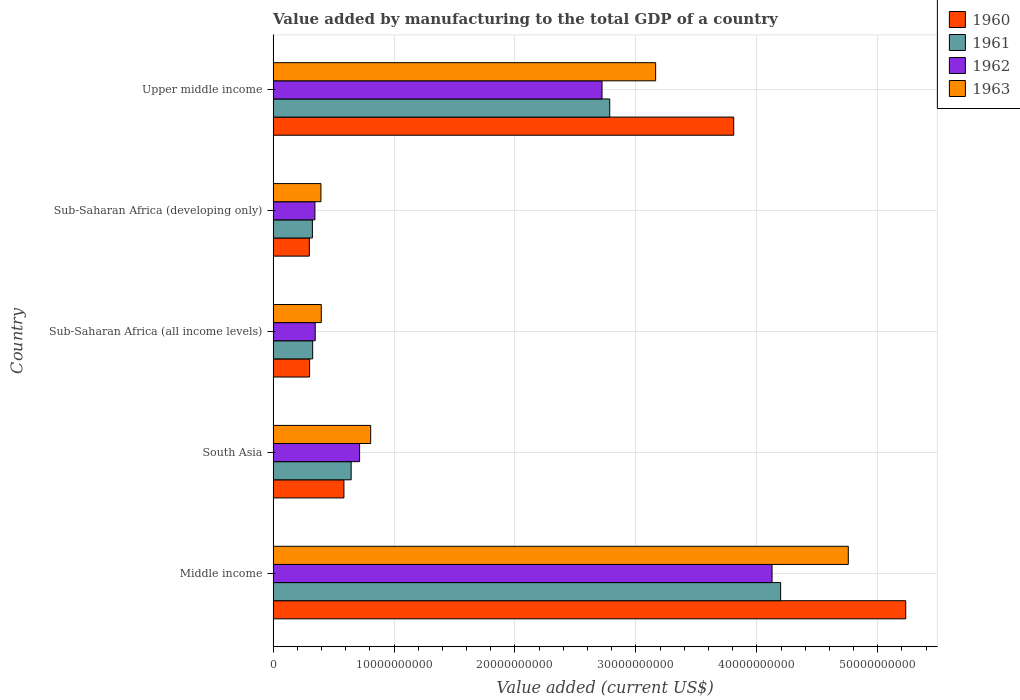How many different coloured bars are there?
Provide a succinct answer. 4. How many groups of bars are there?
Offer a terse response. 5. Are the number of bars per tick equal to the number of legend labels?
Provide a short and direct response. Yes. Are the number of bars on each tick of the Y-axis equal?
Your response must be concise. Yes. How many bars are there on the 4th tick from the bottom?
Make the answer very short. 4. What is the label of the 3rd group of bars from the top?
Keep it short and to the point. Sub-Saharan Africa (all income levels). In how many cases, is the number of bars for a given country not equal to the number of legend labels?
Provide a short and direct response. 0. What is the value added by manufacturing to the total GDP in 1960 in Middle income?
Offer a terse response. 5.23e+1. Across all countries, what is the maximum value added by manufacturing to the total GDP in 1963?
Offer a very short reply. 4.76e+1. Across all countries, what is the minimum value added by manufacturing to the total GDP in 1960?
Provide a succinct answer. 2.99e+09. In which country was the value added by manufacturing to the total GDP in 1963 maximum?
Provide a succinct answer. Middle income. In which country was the value added by manufacturing to the total GDP in 1962 minimum?
Keep it short and to the point. Sub-Saharan Africa (developing only). What is the total value added by manufacturing to the total GDP in 1960 in the graph?
Your answer should be very brief. 1.02e+11. What is the difference between the value added by manufacturing to the total GDP in 1963 in Middle income and that in Upper middle income?
Offer a terse response. 1.59e+1. What is the difference between the value added by manufacturing to the total GDP in 1962 in South Asia and the value added by manufacturing to the total GDP in 1960 in Middle income?
Your answer should be very brief. -4.52e+1. What is the average value added by manufacturing to the total GDP in 1960 per country?
Provide a succinct answer. 2.05e+1. What is the difference between the value added by manufacturing to the total GDP in 1962 and value added by manufacturing to the total GDP in 1961 in Sub-Saharan Africa (developing only)?
Your response must be concise. 2.08e+08. In how many countries, is the value added by manufacturing to the total GDP in 1961 greater than 26000000000 US$?
Provide a short and direct response. 2. What is the ratio of the value added by manufacturing to the total GDP in 1961 in Sub-Saharan Africa (developing only) to that in Upper middle income?
Provide a short and direct response. 0.12. What is the difference between the highest and the second highest value added by manufacturing to the total GDP in 1963?
Your answer should be compact. 1.59e+1. What is the difference between the highest and the lowest value added by manufacturing to the total GDP in 1963?
Ensure brevity in your answer.  4.36e+1. In how many countries, is the value added by manufacturing to the total GDP in 1962 greater than the average value added by manufacturing to the total GDP in 1962 taken over all countries?
Make the answer very short. 2. Is the sum of the value added by manufacturing to the total GDP in 1963 in South Asia and Upper middle income greater than the maximum value added by manufacturing to the total GDP in 1962 across all countries?
Offer a very short reply. No. Is it the case that in every country, the sum of the value added by manufacturing to the total GDP in 1962 and value added by manufacturing to the total GDP in 1961 is greater than the sum of value added by manufacturing to the total GDP in 1960 and value added by manufacturing to the total GDP in 1963?
Your answer should be compact. Yes. What does the 4th bar from the bottom in Sub-Saharan Africa (all income levels) represents?
Offer a terse response. 1963. Is it the case that in every country, the sum of the value added by manufacturing to the total GDP in 1960 and value added by manufacturing to the total GDP in 1962 is greater than the value added by manufacturing to the total GDP in 1961?
Your answer should be compact. Yes. Are the values on the major ticks of X-axis written in scientific E-notation?
Make the answer very short. No. Does the graph contain grids?
Offer a very short reply. Yes. Where does the legend appear in the graph?
Ensure brevity in your answer.  Top right. How are the legend labels stacked?
Keep it short and to the point. Vertical. What is the title of the graph?
Your answer should be compact. Value added by manufacturing to the total GDP of a country. What is the label or title of the X-axis?
Give a very brief answer. Value added (current US$). What is the label or title of the Y-axis?
Make the answer very short. Country. What is the Value added (current US$) of 1960 in Middle income?
Give a very brief answer. 5.23e+1. What is the Value added (current US$) of 1961 in Middle income?
Give a very brief answer. 4.20e+1. What is the Value added (current US$) in 1962 in Middle income?
Make the answer very short. 4.13e+1. What is the Value added (current US$) of 1963 in Middle income?
Your answer should be very brief. 4.76e+1. What is the Value added (current US$) of 1960 in South Asia?
Your answer should be very brief. 5.86e+09. What is the Value added (current US$) in 1961 in South Asia?
Provide a short and direct response. 6.45e+09. What is the Value added (current US$) in 1962 in South Asia?
Your answer should be compact. 7.15e+09. What is the Value added (current US$) in 1963 in South Asia?
Provide a short and direct response. 8.07e+09. What is the Value added (current US$) of 1960 in Sub-Saharan Africa (all income levels)?
Provide a succinct answer. 3.02e+09. What is the Value added (current US$) of 1961 in Sub-Saharan Africa (all income levels)?
Make the answer very short. 3.27e+09. What is the Value added (current US$) of 1962 in Sub-Saharan Africa (all income levels)?
Your answer should be very brief. 3.48e+09. What is the Value added (current US$) of 1963 in Sub-Saharan Africa (all income levels)?
Your answer should be very brief. 3.98e+09. What is the Value added (current US$) in 1960 in Sub-Saharan Africa (developing only)?
Provide a succinct answer. 2.99e+09. What is the Value added (current US$) of 1961 in Sub-Saharan Africa (developing only)?
Your answer should be very brief. 3.25e+09. What is the Value added (current US$) in 1962 in Sub-Saharan Africa (developing only)?
Your answer should be very brief. 3.46e+09. What is the Value added (current US$) of 1963 in Sub-Saharan Africa (developing only)?
Your answer should be very brief. 3.95e+09. What is the Value added (current US$) in 1960 in Upper middle income?
Keep it short and to the point. 3.81e+1. What is the Value added (current US$) in 1961 in Upper middle income?
Your answer should be very brief. 2.78e+1. What is the Value added (current US$) of 1962 in Upper middle income?
Offer a terse response. 2.72e+1. What is the Value added (current US$) of 1963 in Upper middle income?
Provide a succinct answer. 3.16e+1. Across all countries, what is the maximum Value added (current US$) in 1960?
Ensure brevity in your answer.  5.23e+1. Across all countries, what is the maximum Value added (current US$) of 1961?
Offer a very short reply. 4.20e+1. Across all countries, what is the maximum Value added (current US$) in 1962?
Your answer should be very brief. 4.13e+1. Across all countries, what is the maximum Value added (current US$) in 1963?
Your answer should be very brief. 4.76e+1. Across all countries, what is the minimum Value added (current US$) in 1960?
Offer a terse response. 2.99e+09. Across all countries, what is the minimum Value added (current US$) in 1961?
Offer a very short reply. 3.25e+09. Across all countries, what is the minimum Value added (current US$) in 1962?
Offer a terse response. 3.46e+09. Across all countries, what is the minimum Value added (current US$) of 1963?
Your answer should be very brief. 3.95e+09. What is the total Value added (current US$) of 1960 in the graph?
Your answer should be compact. 1.02e+11. What is the total Value added (current US$) in 1961 in the graph?
Your answer should be compact. 8.28e+1. What is the total Value added (current US$) in 1962 in the graph?
Your answer should be very brief. 8.25e+1. What is the total Value added (current US$) of 1963 in the graph?
Your answer should be compact. 9.52e+1. What is the difference between the Value added (current US$) of 1960 in Middle income and that in South Asia?
Your answer should be very brief. 4.65e+1. What is the difference between the Value added (current US$) of 1961 in Middle income and that in South Asia?
Your answer should be very brief. 3.55e+1. What is the difference between the Value added (current US$) in 1962 in Middle income and that in South Asia?
Offer a very short reply. 3.41e+1. What is the difference between the Value added (current US$) in 1963 in Middle income and that in South Asia?
Make the answer very short. 3.95e+1. What is the difference between the Value added (current US$) of 1960 in Middle income and that in Sub-Saharan Africa (all income levels)?
Offer a very short reply. 4.93e+1. What is the difference between the Value added (current US$) in 1961 in Middle income and that in Sub-Saharan Africa (all income levels)?
Keep it short and to the point. 3.87e+1. What is the difference between the Value added (current US$) of 1962 in Middle income and that in Sub-Saharan Africa (all income levels)?
Offer a very short reply. 3.78e+1. What is the difference between the Value added (current US$) of 1963 in Middle income and that in Sub-Saharan Africa (all income levels)?
Your answer should be compact. 4.36e+1. What is the difference between the Value added (current US$) in 1960 in Middle income and that in Sub-Saharan Africa (developing only)?
Make the answer very short. 4.93e+1. What is the difference between the Value added (current US$) of 1961 in Middle income and that in Sub-Saharan Africa (developing only)?
Provide a short and direct response. 3.87e+1. What is the difference between the Value added (current US$) of 1962 in Middle income and that in Sub-Saharan Africa (developing only)?
Your answer should be compact. 3.78e+1. What is the difference between the Value added (current US$) of 1963 in Middle income and that in Sub-Saharan Africa (developing only)?
Make the answer very short. 4.36e+1. What is the difference between the Value added (current US$) in 1960 in Middle income and that in Upper middle income?
Offer a terse response. 1.42e+1. What is the difference between the Value added (current US$) of 1961 in Middle income and that in Upper middle income?
Provide a short and direct response. 1.41e+1. What is the difference between the Value added (current US$) in 1962 in Middle income and that in Upper middle income?
Your response must be concise. 1.41e+1. What is the difference between the Value added (current US$) of 1963 in Middle income and that in Upper middle income?
Make the answer very short. 1.59e+1. What is the difference between the Value added (current US$) in 1960 in South Asia and that in Sub-Saharan Africa (all income levels)?
Provide a succinct answer. 2.84e+09. What is the difference between the Value added (current US$) of 1961 in South Asia and that in Sub-Saharan Africa (all income levels)?
Your answer should be compact. 3.18e+09. What is the difference between the Value added (current US$) of 1962 in South Asia and that in Sub-Saharan Africa (all income levels)?
Make the answer very short. 3.67e+09. What is the difference between the Value added (current US$) in 1963 in South Asia and that in Sub-Saharan Africa (all income levels)?
Provide a succinct answer. 4.08e+09. What is the difference between the Value added (current US$) of 1960 in South Asia and that in Sub-Saharan Africa (developing only)?
Provide a succinct answer. 2.86e+09. What is the difference between the Value added (current US$) of 1961 in South Asia and that in Sub-Saharan Africa (developing only)?
Give a very brief answer. 3.21e+09. What is the difference between the Value added (current US$) of 1962 in South Asia and that in Sub-Saharan Africa (developing only)?
Provide a short and direct response. 3.70e+09. What is the difference between the Value added (current US$) in 1963 in South Asia and that in Sub-Saharan Africa (developing only)?
Provide a short and direct response. 4.11e+09. What is the difference between the Value added (current US$) in 1960 in South Asia and that in Upper middle income?
Provide a succinct answer. -3.22e+1. What is the difference between the Value added (current US$) in 1961 in South Asia and that in Upper middle income?
Provide a succinct answer. -2.14e+1. What is the difference between the Value added (current US$) in 1962 in South Asia and that in Upper middle income?
Your answer should be very brief. -2.00e+1. What is the difference between the Value added (current US$) of 1963 in South Asia and that in Upper middle income?
Keep it short and to the point. -2.36e+1. What is the difference between the Value added (current US$) in 1960 in Sub-Saharan Africa (all income levels) and that in Sub-Saharan Africa (developing only)?
Your answer should be compact. 2.16e+07. What is the difference between the Value added (current US$) of 1961 in Sub-Saharan Africa (all income levels) and that in Sub-Saharan Africa (developing only)?
Keep it short and to the point. 2.34e+07. What is the difference between the Value added (current US$) of 1962 in Sub-Saharan Africa (all income levels) and that in Sub-Saharan Africa (developing only)?
Provide a short and direct response. 2.49e+07. What is the difference between the Value added (current US$) of 1963 in Sub-Saharan Africa (all income levels) and that in Sub-Saharan Africa (developing only)?
Offer a very short reply. 2.85e+07. What is the difference between the Value added (current US$) of 1960 in Sub-Saharan Africa (all income levels) and that in Upper middle income?
Your response must be concise. -3.51e+1. What is the difference between the Value added (current US$) of 1961 in Sub-Saharan Africa (all income levels) and that in Upper middle income?
Keep it short and to the point. -2.46e+1. What is the difference between the Value added (current US$) in 1962 in Sub-Saharan Africa (all income levels) and that in Upper middle income?
Your answer should be compact. -2.37e+1. What is the difference between the Value added (current US$) of 1963 in Sub-Saharan Africa (all income levels) and that in Upper middle income?
Ensure brevity in your answer.  -2.76e+1. What is the difference between the Value added (current US$) in 1960 in Sub-Saharan Africa (developing only) and that in Upper middle income?
Give a very brief answer. -3.51e+1. What is the difference between the Value added (current US$) of 1961 in Sub-Saharan Africa (developing only) and that in Upper middle income?
Provide a succinct answer. -2.46e+1. What is the difference between the Value added (current US$) in 1962 in Sub-Saharan Africa (developing only) and that in Upper middle income?
Your answer should be very brief. -2.37e+1. What is the difference between the Value added (current US$) in 1963 in Sub-Saharan Africa (developing only) and that in Upper middle income?
Offer a terse response. -2.77e+1. What is the difference between the Value added (current US$) of 1960 in Middle income and the Value added (current US$) of 1961 in South Asia?
Make the answer very short. 4.59e+1. What is the difference between the Value added (current US$) of 1960 in Middle income and the Value added (current US$) of 1962 in South Asia?
Provide a short and direct response. 4.52e+1. What is the difference between the Value added (current US$) of 1960 in Middle income and the Value added (current US$) of 1963 in South Asia?
Offer a terse response. 4.42e+1. What is the difference between the Value added (current US$) of 1961 in Middle income and the Value added (current US$) of 1962 in South Asia?
Offer a very short reply. 3.48e+1. What is the difference between the Value added (current US$) in 1961 in Middle income and the Value added (current US$) in 1963 in South Asia?
Give a very brief answer. 3.39e+1. What is the difference between the Value added (current US$) in 1962 in Middle income and the Value added (current US$) in 1963 in South Asia?
Provide a succinct answer. 3.32e+1. What is the difference between the Value added (current US$) of 1960 in Middle income and the Value added (current US$) of 1961 in Sub-Saharan Africa (all income levels)?
Ensure brevity in your answer.  4.90e+1. What is the difference between the Value added (current US$) in 1960 in Middle income and the Value added (current US$) in 1962 in Sub-Saharan Africa (all income levels)?
Provide a succinct answer. 4.88e+1. What is the difference between the Value added (current US$) of 1960 in Middle income and the Value added (current US$) of 1963 in Sub-Saharan Africa (all income levels)?
Offer a very short reply. 4.83e+1. What is the difference between the Value added (current US$) of 1961 in Middle income and the Value added (current US$) of 1962 in Sub-Saharan Africa (all income levels)?
Offer a terse response. 3.85e+1. What is the difference between the Value added (current US$) of 1961 in Middle income and the Value added (current US$) of 1963 in Sub-Saharan Africa (all income levels)?
Provide a short and direct response. 3.80e+1. What is the difference between the Value added (current US$) in 1962 in Middle income and the Value added (current US$) in 1963 in Sub-Saharan Africa (all income levels)?
Your response must be concise. 3.73e+1. What is the difference between the Value added (current US$) in 1960 in Middle income and the Value added (current US$) in 1961 in Sub-Saharan Africa (developing only)?
Provide a succinct answer. 4.91e+1. What is the difference between the Value added (current US$) in 1960 in Middle income and the Value added (current US$) in 1962 in Sub-Saharan Africa (developing only)?
Your answer should be compact. 4.89e+1. What is the difference between the Value added (current US$) of 1960 in Middle income and the Value added (current US$) of 1963 in Sub-Saharan Africa (developing only)?
Offer a very short reply. 4.84e+1. What is the difference between the Value added (current US$) of 1961 in Middle income and the Value added (current US$) of 1962 in Sub-Saharan Africa (developing only)?
Offer a very short reply. 3.85e+1. What is the difference between the Value added (current US$) in 1961 in Middle income and the Value added (current US$) in 1963 in Sub-Saharan Africa (developing only)?
Give a very brief answer. 3.80e+1. What is the difference between the Value added (current US$) in 1962 in Middle income and the Value added (current US$) in 1963 in Sub-Saharan Africa (developing only)?
Your response must be concise. 3.73e+1. What is the difference between the Value added (current US$) of 1960 in Middle income and the Value added (current US$) of 1961 in Upper middle income?
Your answer should be compact. 2.45e+1. What is the difference between the Value added (current US$) of 1960 in Middle income and the Value added (current US$) of 1962 in Upper middle income?
Keep it short and to the point. 2.51e+1. What is the difference between the Value added (current US$) of 1960 in Middle income and the Value added (current US$) of 1963 in Upper middle income?
Keep it short and to the point. 2.07e+1. What is the difference between the Value added (current US$) in 1961 in Middle income and the Value added (current US$) in 1962 in Upper middle income?
Provide a short and direct response. 1.48e+1. What is the difference between the Value added (current US$) of 1961 in Middle income and the Value added (current US$) of 1963 in Upper middle income?
Ensure brevity in your answer.  1.03e+1. What is the difference between the Value added (current US$) of 1962 in Middle income and the Value added (current US$) of 1963 in Upper middle income?
Provide a short and direct response. 9.63e+09. What is the difference between the Value added (current US$) of 1960 in South Asia and the Value added (current US$) of 1961 in Sub-Saharan Africa (all income levels)?
Offer a very short reply. 2.58e+09. What is the difference between the Value added (current US$) in 1960 in South Asia and the Value added (current US$) in 1962 in Sub-Saharan Africa (all income levels)?
Provide a succinct answer. 2.37e+09. What is the difference between the Value added (current US$) in 1960 in South Asia and the Value added (current US$) in 1963 in Sub-Saharan Africa (all income levels)?
Give a very brief answer. 1.87e+09. What is the difference between the Value added (current US$) in 1961 in South Asia and the Value added (current US$) in 1962 in Sub-Saharan Africa (all income levels)?
Your response must be concise. 2.97e+09. What is the difference between the Value added (current US$) in 1961 in South Asia and the Value added (current US$) in 1963 in Sub-Saharan Africa (all income levels)?
Keep it short and to the point. 2.47e+09. What is the difference between the Value added (current US$) in 1962 in South Asia and the Value added (current US$) in 1963 in Sub-Saharan Africa (all income levels)?
Keep it short and to the point. 3.17e+09. What is the difference between the Value added (current US$) in 1960 in South Asia and the Value added (current US$) in 1961 in Sub-Saharan Africa (developing only)?
Ensure brevity in your answer.  2.61e+09. What is the difference between the Value added (current US$) in 1960 in South Asia and the Value added (current US$) in 1962 in Sub-Saharan Africa (developing only)?
Your answer should be compact. 2.40e+09. What is the difference between the Value added (current US$) of 1960 in South Asia and the Value added (current US$) of 1963 in Sub-Saharan Africa (developing only)?
Your answer should be compact. 1.90e+09. What is the difference between the Value added (current US$) of 1961 in South Asia and the Value added (current US$) of 1962 in Sub-Saharan Africa (developing only)?
Your response must be concise. 3.00e+09. What is the difference between the Value added (current US$) of 1961 in South Asia and the Value added (current US$) of 1963 in Sub-Saharan Africa (developing only)?
Offer a very short reply. 2.50e+09. What is the difference between the Value added (current US$) of 1962 in South Asia and the Value added (current US$) of 1963 in Sub-Saharan Africa (developing only)?
Provide a succinct answer. 3.20e+09. What is the difference between the Value added (current US$) in 1960 in South Asia and the Value added (current US$) in 1961 in Upper middle income?
Your answer should be compact. -2.20e+1. What is the difference between the Value added (current US$) of 1960 in South Asia and the Value added (current US$) of 1962 in Upper middle income?
Offer a very short reply. -2.13e+1. What is the difference between the Value added (current US$) of 1960 in South Asia and the Value added (current US$) of 1963 in Upper middle income?
Your response must be concise. -2.58e+1. What is the difference between the Value added (current US$) of 1961 in South Asia and the Value added (current US$) of 1962 in Upper middle income?
Ensure brevity in your answer.  -2.07e+1. What is the difference between the Value added (current US$) of 1961 in South Asia and the Value added (current US$) of 1963 in Upper middle income?
Your response must be concise. -2.52e+1. What is the difference between the Value added (current US$) in 1962 in South Asia and the Value added (current US$) in 1963 in Upper middle income?
Keep it short and to the point. -2.45e+1. What is the difference between the Value added (current US$) of 1960 in Sub-Saharan Africa (all income levels) and the Value added (current US$) of 1961 in Sub-Saharan Africa (developing only)?
Provide a short and direct response. -2.32e+08. What is the difference between the Value added (current US$) in 1960 in Sub-Saharan Africa (all income levels) and the Value added (current US$) in 1962 in Sub-Saharan Africa (developing only)?
Your answer should be compact. -4.40e+08. What is the difference between the Value added (current US$) in 1960 in Sub-Saharan Africa (all income levels) and the Value added (current US$) in 1963 in Sub-Saharan Africa (developing only)?
Offer a very short reply. -9.39e+08. What is the difference between the Value added (current US$) in 1961 in Sub-Saharan Africa (all income levels) and the Value added (current US$) in 1962 in Sub-Saharan Africa (developing only)?
Give a very brief answer. -1.85e+08. What is the difference between the Value added (current US$) of 1961 in Sub-Saharan Africa (all income levels) and the Value added (current US$) of 1963 in Sub-Saharan Africa (developing only)?
Provide a succinct answer. -6.84e+08. What is the difference between the Value added (current US$) of 1962 in Sub-Saharan Africa (all income levels) and the Value added (current US$) of 1963 in Sub-Saharan Africa (developing only)?
Keep it short and to the point. -4.74e+08. What is the difference between the Value added (current US$) of 1960 in Sub-Saharan Africa (all income levels) and the Value added (current US$) of 1961 in Upper middle income?
Ensure brevity in your answer.  -2.48e+1. What is the difference between the Value added (current US$) in 1960 in Sub-Saharan Africa (all income levels) and the Value added (current US$) in 1962 in Upper middle income?
Give a very brief answer. -2.42e+1. What is the difference between the Value added (current US$) of 1960 in Sub-Saharan Africa (all income levels) and the Value added (current US$) of 1963 in Upper middle income?
Offer a terse response. -2.86e+1. What is the difference between the Value added (current US$) of 1961 in Sub-Saharan Africa (all income levels) and the Value added (current US$) of 1962 in Upper middle income?
Keep it short and to the point. -2.39e+1. What is the difference between the Value added (current US$) in 1961 in Sub-Saharan Africa (all income levels) and the Value added (current US$) in 1963 in Upper middle income?
Provide a short and direct response. -2.84e+1. What is the difference between the Value added (current US$) in 1962 in Sub-Saharan Africa (all income levels) and the Value added (current US$) in 1963 in Upper middle income?
Give a very brief answer. -2.82e+1. What is the difference between the Value added (current US$) in 1960 in Sub-Saharan Africa (developing only) and the Value added (current US$) in 1961 in Upper middle income?
Ensure brevity in your answer.  -2.48e+1. What is the difference between the Value added (current US$) in 1960 in Sub-Saharan Africa (developing only) and the Value added (current US$) in 1962 in Upper middle income?
Your answer should be very brief. -2.42e+1. What is the difference between the Value added (current US$) in 1960 in Sub-Saharan Africa (developing only) and the Value added (current US$) in 1963 in Upper middle income?
Offer a terse response. -2.86e+1. What is the difference between the Value added (current US$) in 1961 in Sub-Saharan Africa (developing only) and the Value added (current US$) in 1962 in Upper middle income?
Provide a succinct answer. -2.40e+1. What is the difference between the Value added (current US$) in 1961 in Sub-Saharan Africa (developing only) and the Value added (current US$) in 1963 in Upper middle income?
Your answer should be very brief. -2.84e+1. What is the difference between the Value added (current US$) in 1962 in Sub-Saharan Africa (developing only) and the Value added (current US$) in 1963 in Upper middle income?
Your answer should be compact. -2.82e+1. What is the average Value added (current US$) in 1960 per country?
Ensure brevity in your answer.  2.05e+1. What is the average Value added (current US$) of 1961 per country?
Ensure brevity in your answer.  1.66e+1. What is the average Value added (current US$) of 1962 per country?
Your answer should be compact. 1.65e+1. What is the average Value added (current US$) of 1963 per country?
Your response must be concise. 1.90e+1. What is the difference between the Value added (current US$) in 1960 and Value added (current US$) in 1961 in Middle income?
Your answer should be compact. 1.03e+1. What is the difference between the Value added (current US$) of 1960 and Value added (current US$) of 1962 in Middle income?
Make the answer very short. 1.11e+1. What is the difference between the Value added (current US$) of 1960 and Value added (current US$) of 1963 in Middle income?
Make the answer very short. 4.75e+09. What is the difference between the Value added (current US$) in 1961 and Value added (current US$) in 1962 in Middle income?
Provide a succinct answer. 7.12e+08. What is the difference between the Value added (current US$) of 1961 and Value added (current US$) of 1963 in Middle income?
Offer a terse response. -5.59e+09. What is the difference between the Value added (current US$) of 1962 and Value added (current US$) of 1963 in Middle income?
Keep it short and to the point. -6.31e+09. What is the difference between the Value added (current US$) in 1960 and Value added (current US$) in 1961 in South Asia?
Your answer should be very brief. -5.98e+08. What is the difference between the Value added (current US$) in 1960 and Value added (current US$) in 1962 in South Asia?
Your answer should be compact. -1.30e+09. What is the difference between the Value added (current US$) of 1960 and Value added (current US$) of 1963 in South Asia?
Ensure brevity in your answer.  -2.21e+09. What is the difference between the Value added (current US$) of 1961 and Value added (current US$) of 1962 in South Asia?
Your response must be concise. -6.98e+08. What is the difference between the Value added (current US$) of 1961 and Value added (current US$) of 1963 in South Asia?
Give a very brief answer. -1.61e+09. What is the difference between the Value added (current US$) in 1962 and Value added (current US$) in 1963 in South Asia?
Keep it short and to the point. -9.17e+08. What is the difference between the Value added (current US$) in 1960 and Value added (current US$) in 1961 in Sub-Saharan Africa (all income levels)?
Offer a very short reply. -2.55e+08. What is the difference between the Value added (current US$) in 1960 and Value added (current US$) in 1962 in Sub-Saharan Africa (all income levels)?
Ensure brevity in your answer.  -4.65e+08. What is the difference between the Value added (current US$) of 1960 and Value added (current US$) of 1963 in Sub-Saharan Africa (all income levels)?
Offer a terse response. -9.68e+08. What is the difference between the Value added (current US$) in 1961 and Value added (current US$) in 1962 in Sub-Saharan Africa (all income levels)?
Keep it short and to the point. -2.09e+08. What is the difference between the Value added (current US$) of 1961 and Value added (current US$) of 1963 in Sub-Saharan Africa (all income levels)?
Provide a succinct answer. -7.12e+08. What is the difference between the Value added (current US$) in 1962 and Value added (current US$) in 1963 in Sub-Saharan Africa (all income levels)?
Offer a very short reply. -5.03e+08. What is the difference between the Value added (current US$) of 1960 and Value added (current US$) of 1961 in Sub-Saharan Africa (developing only)?
Provide a succinct answer. -2.54e+08. What is the difference between the Value added (current US$) in 1960 and Value added (current US$) in 1962 in Sub-Saharan Africa (developing only)?
Offer a terse response. -4.61e+08. What is the difference between the Value added (current US$) of 1960 and Value added (current US$) of 1963 in Sub-Saharan Africa (developing only)?
Offer a very short reply. -9.61e+08. What is the difference between the Value added (current US$) of 1961 and Value added (current US$) of 1962 in Sub-Saharan Africa (developing only)?
Your answer should be compact. -2.08e+08. What is the difference between the Value added (current US$) of 1961 and Value added (current US$) of 1963 in Sub-Saharan Africa (developing only)?
Your answer should be compact. -7.07e+08. What is the difference between the Value added (current US$) in 1962 and Value added (current US$) in 1963 in Sub-Saharan Africa (developing only)?
Give a very brief answer. -4.99e+08. What is the difference between the Value added (current US$) in 1960 and Value added (current US$) in 1961 in Upper middle income?
Ensure brevity in your answer.  1.03e+1. What is the difference between the Value added (current US$) of 1960 and Value added (current US$) of 1962 in Upper middle income?
Provide a succinct answer. 1.09e+1. What is the difference between the Value added (current US$) in 1960 and Value added (current US$) in 1963 in Upper middle income?
Keep it short and to the point. 6.46e+09. What is the difference between the Value added (current US$) of 1961 and Value added (current US$) of 1962 in Upper middle income?
Ensure brevity in your answer.  6.38e+08. What is the difference between the Value added (current US$) of 1961 and Value added (current US$) of 1963 in Upper middle income?
Make the answer very short. -3.80e+09. What is the difference between the Value added (current US$) of 1962 and Value added (current US$) of 1963 in Upper middle income?
Give a very brief answer. -4.43e+09. What is the ratio of the Value added (current US$) in 1960 in Middle income to that in South Asia?
Provide a succinct answer. 8.93. What is the ratio of the Value added (current US$) of 1961 in Middle income to that in South Asia?
Your response must be concise. 6.5. What is the ratio of the Value added (current US$) of 1962 in Middle income to that in South Asia?
Your answer should be very brief. 5.77. What is the ratio of the Value added (current US$) of 1963 in Middle income to that in South Asia?
Your response must be concise. 5.9. What is the ratio of the Value added (current US$) in 1960 in Middle income to that in Sub-Saharan Africa (all income levels)?
Your response must be concise. 17.35. What is the ratio of the Value added (current US$) in 1961 in Middle income to that in Sub-Saharan Africa (all income levels)?
Keep it short and to the point. 12.83. What is the ratio of the Value added (current US$) of 1962 in Middle income to that in Sub-Saharan Africa (all income levels)?
Ensure brevity in your answer.  11.85. What is the ratio of the Value added (current US$) in 1963 in Middle income to that in Sub-Saharan Africa (all income levels)?
Make the answer very short. 11.94. What is the ratio of the Value added (current US$) in 1960 in Middle income to that in Sub-Saharan Africa (developing only)?
Provide a succinct answer. 17.47. What is the ratio of the Value added (current US$) in 1961 in Middle income to that in Sub-Saharan Africa (developing only)?
Your answer should be very brief. 12.92. What is the ratio of the Value added (current US$) in 1962 in Middle income to that in Sub-Saharan Africa (developing only)?
Keep it short and to the point. 11.94. What is the ratio of the Value added (current US$) in 1963 in Middle income to that in Sub-Saharan Africa (developing only)?
Offer a very short reply. 12.03. What is the ratio of the Value added (current US$) of 1960 in Middle income to that in Upper middle income?
Give a very brief answer. 1.37. What is the ratio of the Value added (current US$) in 1961 in Middle income to that in Upper middle income?
Your answer should be compact. 1.51. What is the ratio of the Value added (current US$) in 1962 in Middle income to that in Upper middle income?
Keep it short and to the point. 1.52. What is the ratio of the Value added (current US$) in 1963 in Middle income to that in Upper middle income?
Your answer should be compact. 1.5. What is the ratio of the Value added (current US$) in 1960 in South Asia to that in Sub-Saharan Africa (all income levels)?
Keep it short and to the point. 1.94. What is the ratio of the Value added (current US$) in 1961 in South Asia to that in Sub-Saharan Africa (all income levels)?
Keep it short and to the point. 1.97. What is the ratio of the Value added (current US$) of 1962 in South Asia to that in Sub-Saharan Africa (all income levels)?
Provide a succinct answer. 2.05. What is the ratio of the Value added (current US$) in 1963 in South Asia to that in Sub-Saharan Africa (all income levels)?
Your answer should be compact. 2.03. What is the ratio of the Value added (current US$) in 1960 in South Asia to that in Sub-Saharan Africa (developing only)?
Offer a terse response. 1.96. What is the ratio of the Value added (current US$) in 1961 in South Asia to that in Sub-Saharan Africa (developing only)?
Offer a terse response. 1.99. What is the ratio of the Value added (current US$) in 1962 in South Asia to that in Sub-Saharan Africa (developing only)?
Your answer should be very brief. 2.07. What is the ratio of the Value added (current US$) in 1963 in South Asia to that in Sub-Saharan Africa (developing only)?
Provide a short and direct response. 2.04. What is the ratio of the Value added (current US$) of 1960 in South Asia to that in Upper middle income?
Your answer should be compact. 0.15. What is the ratio of the Value added (current US$) of 1961 in South Asia to that in Upper middle income?
Your answer should be very brief. 0.23. What is the ratio of the Value added (current US$) in 1962 in South Asia to that in Upper middle income?
Ensure brevity in your answer.  0.26. What is the ratio of the Value added (current US$) in 1963 in South Asia to that in Upper middle income?
Keep it short and to the point. 0.26. What is the ratio of the Value added (current US$) in 1961 in Sub-Saharan Africa (all income levels) to that in Sub-Saharan Africa (developing only)?
Make the answer very short. 1.01. What is the ratio of the Value added (current US$) of 1960 in Sub-Saharan Africa (all income levels) to that in Upper middle income?
Your response must be concise. 0.08. What is the ratio of the Value added (current US$) in 1961 in Sub-Saharan Africa (all income levels) to that in Upper middle income?
Give a very brief answer. 0.12. What is the ratio of the Value added (current US$) in 1962 in Sub-Saharan Africa (all income levels) to that in Upper middle income?
Your response must be concise. 0.13. What is the ratio of the Value added (current US$) in 1963 in Sub-Saharan Africa (all income levels) to that in Upper middle income?
Your response must be concise. 0.13. What is the ratio of the Value added (current US$) in 1960 in Sub-Saharan Africa (developing only) to that in Upper middle income?
Ensure brevity in your answer.  0.08. What is the ratio of the Value added (current US$) in 1961 in Sub-Saharan Africa (developing only) to that in Upper middle income?
Ensure brevity in your answer.  0.12. What is the ratio of the Value added (current US$) of 1962 in Sub-Saharan Africa (developing only) to that in Upper middle income?
Ensure brevity in your answer.  0.13. What is the difference between the highest and the second highest Value added (current US$) of 1960?
Your answer should be compact. 1.42e+1. What is the difference between the highest and the second highest Value added (current US$) in 1961?
Ensure brevity in your answer.  1.41e+1. What is the difference between the highest and the second highest Value added (current US$) of 1962?
Keep it short and to the point. 1.41e+1. What is the difference between the highest and the second highest Value added (current US$) in 1963?
Give a very brief answer. 1.59e+1. What is the difference between the highest and the lowest Value added (current US$) in 1960?
Your answer should be compact. 4.93e+1. What is the difference between the highest and the lowest Value added (current US$) of 1961?
Make the answer very short. 3.87e+1. What is the difference between the highest and the lowest Value added (current US$) of 1962?
Offer a terse response. 3.78e+1. What is the difference between the highest and the lowest Value added (current US$) of 1963?
Make the answer very short. 4.36e+1. 